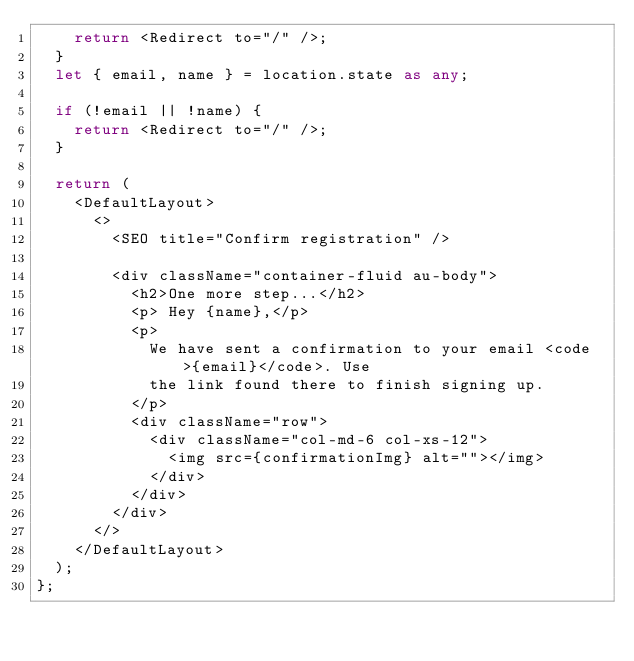<code> <loc_0><loc_0><loc_500><loc_500><_TypeScript_>    return <Redirect to="/" />;
  }
  let { email, name } = location.state as any;

  if (!email || !name) {
    return <Redirect to="/" />;
  }

  return (
    <DefaultLayout>
      <>
        <SEO title="Confirm registration" />

        <div className="container-fluid au-body">
          <h2>One more step...</h2>
          <p> Hey {name},</p>
          <p>
            We have sent a confirmation to your email <code>{email}</code>. Use
            the link found there to finish signing up.
          </p>
          <div className="row">
            <div className="col-md-6 col-xs-12">
              <img src={confirmationImg} alt=""></img>
            </div>
          </div>
        </div>
      </>
    </DefaultLayout>
  );
};
</code> 